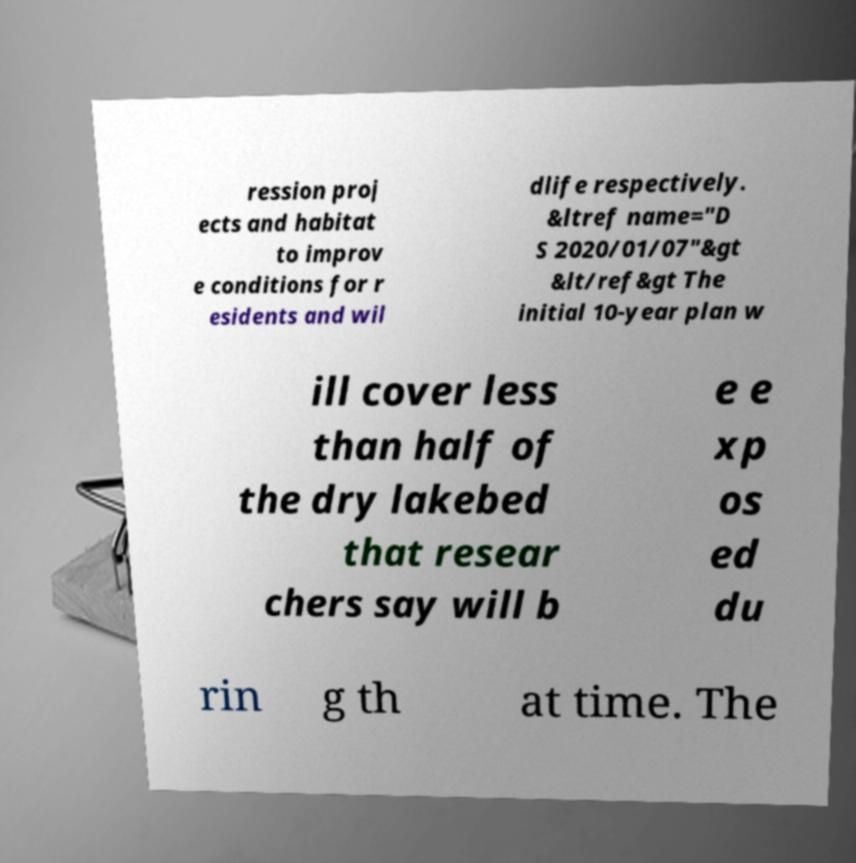Can you read and provide the text displayed in the image?This photo seems to have some interesting text. Can you extract and type it out for me? ression proj ects and habitat to improv e conditions for r esidents and wil dlife respectively. &ltref name="D S 2020/01/07"&gt &lt/ref&gt The initial 10-year plan w ill cover less than half of the dry lakebed that resear chers say will b e e xp os ed du rin g th at time. The 